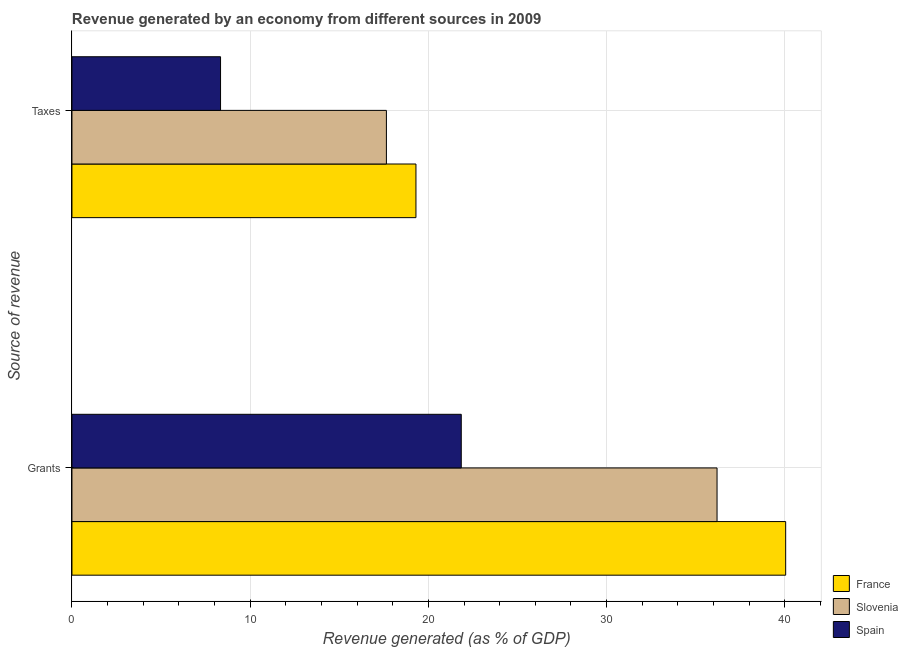How many different coloured bars are there?
Your response must be concise. 3. How many groups of bars are there?
Offer a very short reply. 2. Are the number of bars per tick equal to the number of legend labels?
Your answer should be compact. Yes. What is the label of the 2nd group of bars from the top?
Offer a terse response. Grants. What is the revenue generated by taxes in Spain?
Give a very brief answer. 8.34. Across all countries, what is the maximum revenue generated by taxes?
Offer a very short reply. 19.3. Across all countries, what is the minimum revenue generated by taxes?
Provide a succinct answer. 8.34. In which country was the revenue generated by taxes maximum?
Give a very brief answer. France. What is the total revenue generated by grants in the graph?
Give a very brief answer. 98.09. What is the difference between the revenue generated by taxes in France and that in Spain?
Offer a very short reply. 10.97. What is the difference between the revenue generated by taxes in Slovenia and the revenue generated by grants in Spain?
Make the answer very short. -4.2. What is the average revenue generated by grants per country?
Ensure brevity in your answer.  32.7. What is the difference between the revenue generated by grants and revenue generated by taxes in Slovenia?
Provide a short and direct response. 18.55. In how many countries, is the revenue generated by taxes greater than 16 %?
Give a very brief answer. 2. What is the ratio of the revenue generated by taxes in Spain to that in Slovenia?
Offer a terse response. 0.47. In how many countries, is the revenue generated by grants greater than the average revenue generated by grants taken over all countries?
Keep it short and to the point. 2. What does the 2nd bar from the bottom in Taxes represents?
Make the answer very short. Slovenia. Are all the bars in the graph horizontal?
Ensure brevity in your answer.  Yes. How many countries are there in the graph?
Make the answer very short. 3. Does the graph contain grids?
Keep it short and to the point. Yes. Where does the legend appear in the graph?
Your answer should be very brief. Bottom right. How many legend labels are there?
Provide a succinct answer. 3. How are the legend labels stacked?
Ensure brevity in your answer.  Vertical. What is the title of the graph?
Your answer should be very brief. Revenue generated by an economy from different sources in 2009. What is the label or title of the X-axis?
Ensure brevity in your answer.  Revenue generated (as % of GDP). What is the label or title of the Y-axis?
Keep it short and to the point. Source of revenue. What is the Revenue generated (as % of GDP) in France in Grants?
Your response must be concise. 40.05. What is the Revenue generated (as % of GDP) of Slovenia in Grants?
Your answer should be very brief. 36.2. What is the Revenue generated (as % of GDP) of Spain in Grants?
Give a very brief answer. 21.84. What is the Revenue generated (as % of GDP) in France in Taxes?
Keep it short and to the point. 19.3. What is the Revenue generated (as % of GDP) in Slovenia in Taxes?
Your response must be concise. 17.64. What is the Revenue generated (as % of GDP) in Spain in Taxes?
Your response must be concise. 8.34. Across all Source of revenue, what is the maximum Revenue generated (as % of GDP) of France?
Your answer should be compact. 40.05. Across all Source of revenue, what is the maximum Revenue generated (as % of GDP) in Slovenia?
Ensure brevity in your answer.  36.2. Across all Source of revenue, what is the maximum Revenue generated (as % of GDP) of Spain?
Provide a short and direct response. 21.84. Across all Source of revenue, what is the minimum Revenue generated (as % of GDP) of France?
Your response must be concise. 19.3. Across all Source of revenue, what is the minimum Revenue generated (as % of GDP) in Slovenia?
Ensure brevity in your answer.  17.64. Across all Source of revenue, what is the minimum Revenue generated (as % of GDP) in Spain?
Offer a terse response. 8.34. What is the total Revenue generated (as % of GDP) of France in the graph?
Give a very brief answer. 59.35. What is the total Revenue generated (as % of GDP) of Slovenia in the graph?
Your answer should be very brief. 53.84. What is the total Revenue generated (as % of GDP) of Spain in the graph?
Give a very brief answer. 30.18. What is the difference between the Revenue generated (as % of GDP) in France in Grants and that in Taxes?
Provide a short and direct response. 20.74. What is the difference between the Revenue generated (as % of GDP) of Slovenia in Grants and that in Taxes?
Your answer should be compact. 18.55. What is the difference between the Revenue generated (as % of GDP) in Spain in Grants and that in Taxes?
Keep it short and to the point. 13.51. What is the difference between the Revenue generated (as % of GDP) of France in Grants and the Revenue generated (as % of GDP) of Slovenia in Taxes?
Give a very brief answer. 22.4. What is the difference between the Revenue generated (as % of GDP) in France in Grants and the Revenue generated (as % of GDP) in Spain in Taxes?
Ensure brevity in your answer.  31.71. What is the difference between the Revenue generated (as % of GDP) of Slovenia in Grants and the Revenue generated (as % of GDP) of Spain in Taxes?
Keep it short and to the point. 27.86. What is the average Revenue generated (as % of GDP) in France per Source of revenue?
Provide a succinct answer. 29.67. What is the average Revenue generated (as % of GDP) in Slovenia per Source of revenue?
Your response must be concise. 26.92. What is the average Revenue generated (as % of GDP) in Spain per Source of revenue?
Offer a terse response. 15.09. What is the difference between the Revenue generated (as % of GDP) of France and Revenue generated (as % of GDP) of Slovenia in Grants?
Provide a short and direct response. 3.85. What is the difference between the Revenue generated (as % of GDP) in France and Revenue generated (as % of GDP) in Spain in Grants?
Your answer should be very brief. 18.2. What is the difference between the Revenue generated (as % of GDP) in Slovenia and Revenue generated (as % of GDP) in Spain in Grants?
Your answer should be very brief. 14.35. What is the difference between the Revenue generated (as % of GDP) in France and Revenue generated (as % of GDP) in Slovenia in Taxes?
Offer a terse response. 1.66. What is the difference between the Revenue generated (as % of GDP) of France and Revenue generated (as % of GDP) of Spain in Taxes?
Offer a very short reply. 10.96. What is the difference between the Revenue generated (as % of GDP) of Slovenia and Revenue generated (as % of GDP) of Spain in Taxes?
Give a very brief answer. 9.31. What is the ratio of the Revenue generated (as % of GDP) of France in Grants to that in Taxes?
Ensure brevity in your answer.  2.07. What is the ratio of the Revenue generated (as % of GDP) in Slovenia in Grants to that in Taxes?
Your response must be concise. 2.05. What is the ratio of the Revenue generated (as % of GDP) of Spain in Grants to that in Taxes?
Make the answer very short. 2.62. What is the difference between the highest and the second highest Revenue generated (as % of GDP) of France?
Your answer should be compact. 20.74. What is the difference between the highest and the second highest Revenue generated (as % of GDP) in Slovenia?
Your answer should be very brief. 18.55. What is the difference between the highest and the second highest Revenue generated (as % of GDP) in Spain?
Offer a terse response. 13.51. What is the difference between the highest and the lowest Revenue generated (as % of GDP) in France?
Offer a terse response. 20.74. What is the difference between the highest and the lowest Revenue generated (as % of GDP) in Slovenia?
Your answer should be very brief. 18.55. What is the difference between the highest and the lowest Revenue generated (as % of GDP) of Spain?
Offer a terse response. 13.51. 